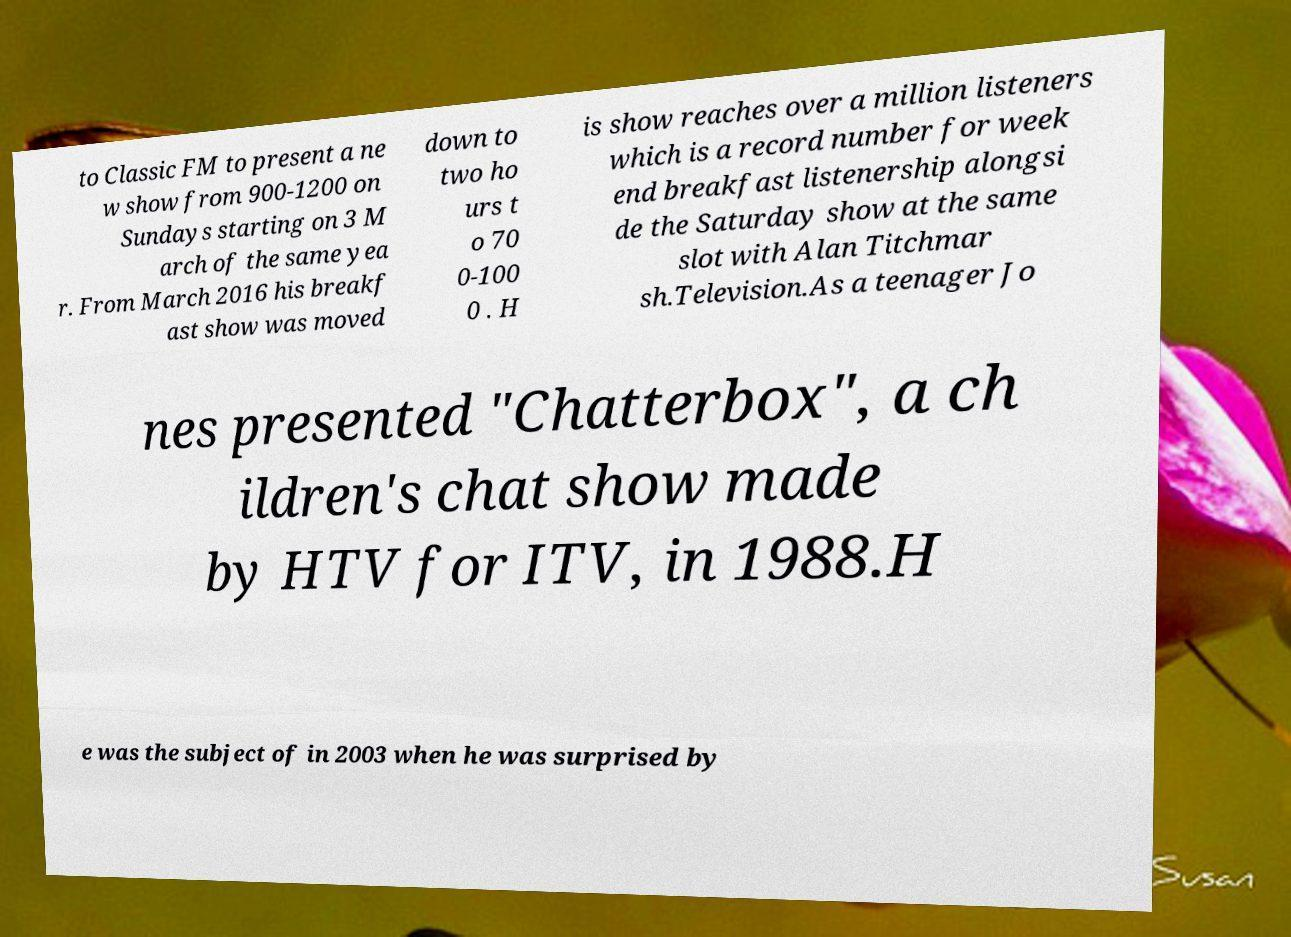Please read and relay the text visible in this image. What does it say? to Classic FM to present a ne w show from 900-1200 on Sundays starting on 3 M arch of the same yea r. From March 2016 his breakf ast show was moved down to two ho urs t o 70 0-100 0 . H is show reaches over a million listeners which is a record number for week end breakfast listenership alongsi de the Saturday show at the same slot with Alan Titchmar sh.Television.As a teenager Jo nes presented "Chatterbox", a ch ildren's chat show made by HTV for ITV, in 1988.H e was the subject of in 2003 when he was surprised by 